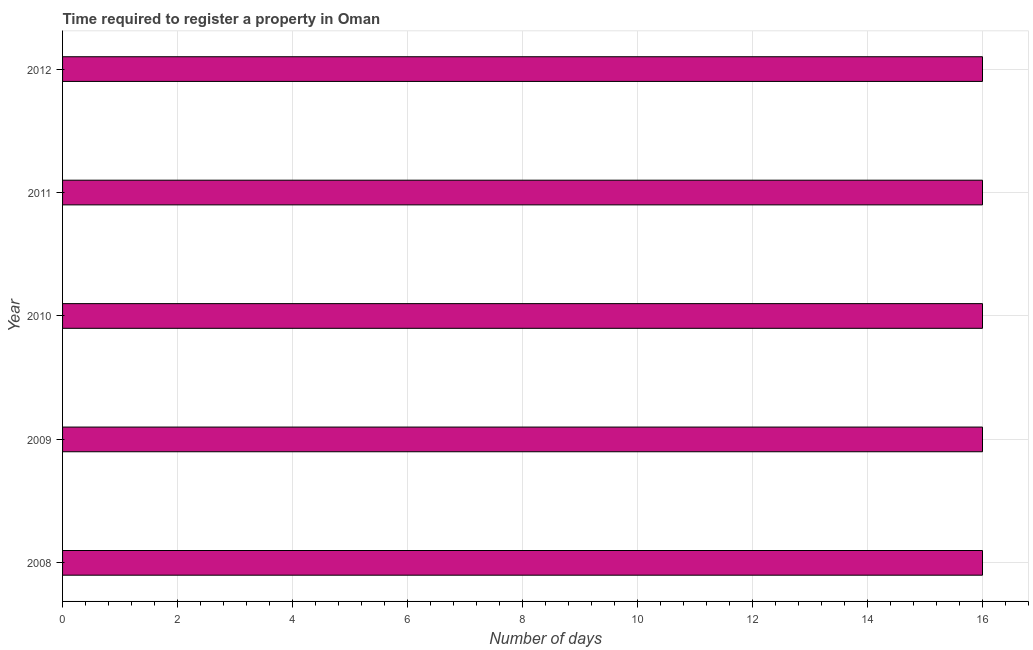Does the graph contain any zero values?
Provide a succinct answer. No. Does the graph contain grids?
Offer a very short reply. Yes. What is the title of the graph?
Your response must be concise. Time required to register a property in Oman. What is the label or title of the X-axis?
Your response must be concise. Number of days. Across all years, what is the maximum number of days required to register property?
Provide a succinct answer. 16. Across all years, what is the minimum number of days required to register property?
Offer a terse response. 16. In which year was the number of days required to register property maximum?
Make the answer very short. 2008. In which year was the number of days required to register property minimum?
Offer a terse response. 2008. What is the sum of the number of days required to register property?
Your answer should be compact. 80. What is the difference between the number of days required to register property in 2008 and 2011?
Your answer should be compact. 0. What is the average number of days required to register property per year?
Your answer should be compact. 16. In how many years, is the number of days required to register property greater than 2.8 days?
Your answer should be very brief. 5. Do a majority of the years between 2011 and 2012 (inclusive) have number of days required to register property greater than 4.4 days?
Keep it short and to the point. Yes. Is the difference between the number of days required to register property in 2008 and 2009 greater than the difference between any two years?
Your answer should be compact. Yes. What is the difference between the highest and the second highest number of days required to register property?
Keep it short and to the point. 0. Is the sum of the number of days required to register property in 2008 and 2011 greater than the maximum number of days required to register property across all years?
Keep it short and to the point. Yes. In how many years, is the number of days required to register property greater than the average number of days required to register property taken over all years?
Provide a short and direct response. 0. How many bars are there?
Keep it short and to the point. 5. How many years are there in the graph?
Offer a terse response. 5. Are the values on the major ticks of X-axis written in scientific E-notation?
Give a very brief answer. No. What is the Number of days of 2008?
Your response must be concise. 16. What is the Number of days of 2010?
Offer a terse response. 16. What is the Number of days in 2011?
Ensure brevity in your answer.  16. What is the Number of days in 2012?
Your answer should be very brief. 16. What is the difference between the Number of days in 2008 and 2009?
Your response must be concise. 0. What is the difference between the Number of days in 2008 and 2012?
Ensure brevity in your answer.  0. What is the difference between the Number of days in 2010 and 2012?
Your answer should be compact. 0. What is the difference between the Number of days in 2011 and 2012?
Your response must be concise. 0. What is the ratio of the Number of days in 2009 to that in 2012?
Give a very brief answer. 1. What is the ratio of the Number of days in 2010 to that in 2011?
Your response must be concise. 1. What is the ratio of the Number of days in 2010 to that in 2012?
Offer a very short reply. 1. What is the ratio of the Number of days in 2011 to that in 2012?
Ensure brevity in your answer.  1. 